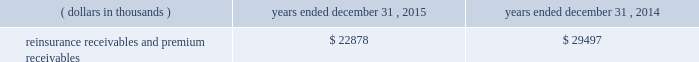Certain reclassifications and format changes have been made to prior years 2019 amounts to conform to the 2015 presentation .
Investments .
Fixed maturity and equity security investments available for sale , at market value , reflect unrealized appreciation and depreciation , as a result of temporary changes in market value during the period , in shareholders 2019 equity , net of income taxes in 201caccumulated other comprehensive income ( loss ) 201d in the consolidated balance sheets .
Fixed maturity and equity securities carried at fair value reflect fair value re- measurements as net realized capital gains and losses in the consolidated statements of operations and comprehensive income ( loss ) .
The company records changes in fair value for its fixed maturities available for sale , at market value through shareholders 2019 equity , net of taxes in accumulated other comprehensive income ( loss ) since cash flows from these investments will be primarily used to settle its reserve for losses and loss adjustment expense liabilities .
The company anticipates holding these investments for an extended period as the cash flow from interest and maturities will fund the projected payout of these liabilities .
Fixed maturities carried at fair value represent a portfolio of convertible bond securities , which have characteristics similar to equity securities and at times , designated foreign denominated fixed maturity securities , which will be used to settle loss and loss adjustment reserves in the same currency .
The company carries all of its equity securities at fair value except for mutual fund investments whose underlying investments are comprised of fixed maturity securities .
For equity securities , available for sale , at fair value , the company reflects changes in value as net realized capital gains and losses since these securities may be sold in the near term depending on financial market conditions .
Interest income on all fixed maturities and dividend income on all equity securities are included as part of net investment income in the consolidated statements of operations and comprehensive income ( loss ) .
Unrealized losses on fixed maturities , which are deemed other-than-temporary and related to the credit quality of a security , are charged to net income ( loss ) as net realized capital losses .
Short-term investments are stated at cost , which approximates market value .
Realized gains or losses on sales of investments are determined on the basis of identified cost .
For non- publicly traded securities , market prices are determined through the use of pricing models that evaluate securities relative to the u.s .
Treasury yield curve , taking into account the issue type , credit quality , and cash flow characteristics of each security .
For publicly traded securities , market value is based on quoted market prices or valuation models that use observable market inputs .
When a sector of the financial markets is inactive or illiquid , the company may use its own assumptions about future cash flows and risk-adjusted discount rates to determine fair value .
Retrospective adjustments are employed to recalculate the values of asset-backed securities .
Each acquisition lot is reviewed to recalculate the effective yield .
The recalculated effective yield is used to derive a book value as if the new yield were applied at the time of acquisition .
Outstanding principal factors from the time of acquisition to the adjustment date are used to calculate the prepayment history for all applicable securities .
Conditional prepayment rates , computed with life to date factor histories and weighted average maturities , are used to effect the calculation of projected and prepayments for pass-through security types .
Other invested assets include limited partnerships and rabbi trusts .
Limited partnerships are accounted for under the equity method of accounting , which can be recorded on a monthly or quarterly lag .
Uncollectible receivable balances .
The company provides reserves for uncollectible reinsurance recoverable and premium receivable balances based on management 2019s assessment of the collectability of the outstanding balances .
Such reserves are presented in the table below for the periods indicated. .

What is the net change in the balance of reinsurance receivables and premium receivables from 2014 to 2015? 
Computations: (22878 - 29497)
Answer: -6619.0. 